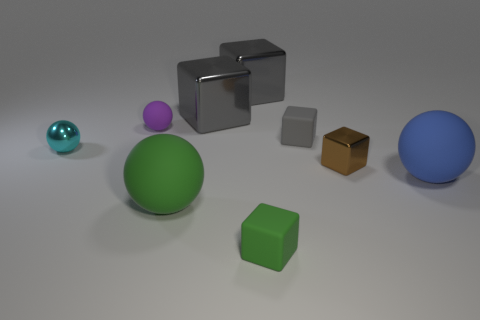There is a sphere behind the cyan metallic sphere; how many big blue matte spheres are on the right side of it?
Ensure brevity in your answer.  1. What number of small matte objects are both behind the large blue rubber ball and on the right side of the green matte ball?
Offer a terse response. 1. What number of objects are tiny shiny things that are on the left side of the green matte block or small matte things that are to the right of the large green matte ball?
Provide a short and direct response. 3. How many other things are there of the same size as the blue sphere?
Your answer should be very brief. 3. The small matte object that is in front of the tiny matte cube that is behind the small metallic ball is what shape?
Keep it short and to the point. Cube. There is a small object in front of the blue matte sphere; does it have the same color as the large ball that is left of the small brown thing?
Provide a succinct answer. Yes. Is there any other thing that is the same color as the tiny matte ball?
Provide a short and direct response. No. What is the color of the small rubber ball?
Give a very brief answer. Purple. Is there a brown cylinder?
Offer a very short reply. No. There is a big blue thing; are there any green rubber balls to the right of it?
Your response must be concise. No. 